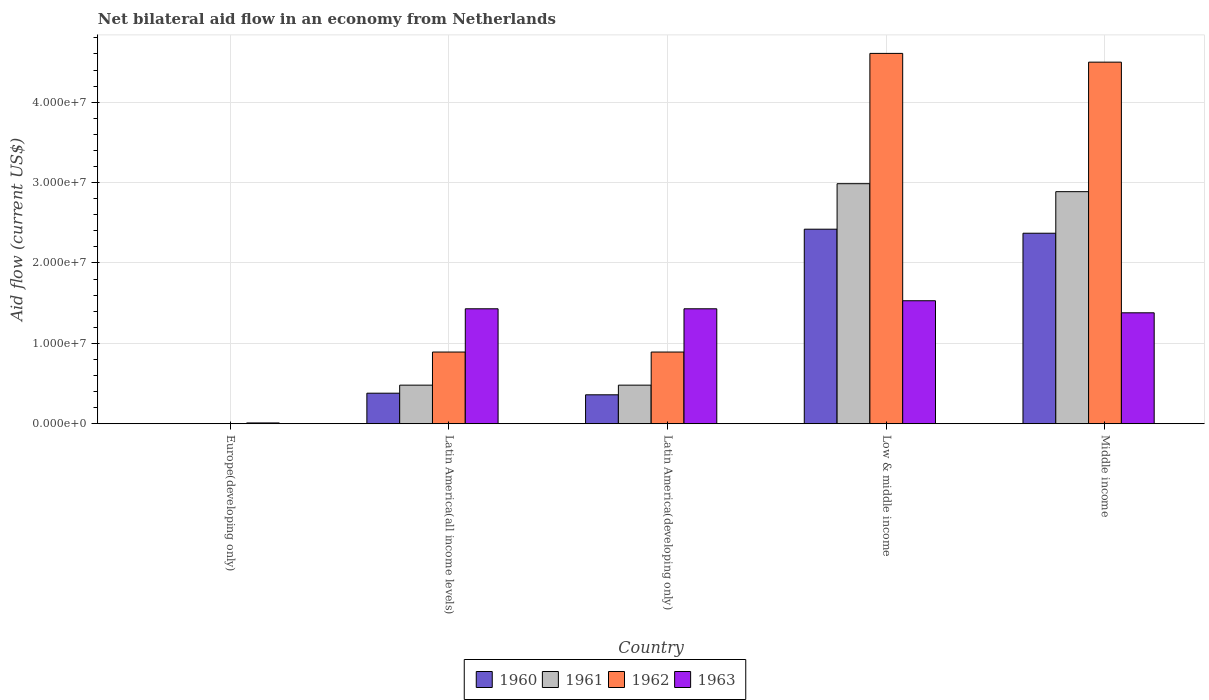How many different coloured bars are there?
Provide a succinct answer. 4. What is the label of the 5th group of bars from the left?
Ensure brevity in your answer.  Middle income. In how many cases, is the number of bars for a given country not equal to the number of legend labels?
Your response must be concise. 1. What is the net bilateral aid flow in 1962 in Europe(developing only)?
Give a very brief answer. 0. Across all countries, what is the maximum net bilateral aid flow in 1961?
Your answer should be very brief. 2.99e+07. Across all countries, what is the minimum net bilateral aid flow in 1961?
Your response must be concise. 0. In which country was the net bilateral aid flow in 1961 maximum?
Provide a succinct answer. Low & middle income. What is the total net bilateral aid flow in 1963 in the graph?
Make the answer very short. 5.78e+07. What is the difference between the net bilateral aid flow in 1961 in Low & middle income and the net bilateral aid flow in 1963 in Latin America(all income levels)?
Your response must be concise. 1.56e+07. What is the average net bilateral aid flow in 1963 per country?
Your answer should be very brief. 1.16e+07. What is the ratio of the net bilateral aid flow in 1962 in Latin America(all income levels) to that in Middle income?
Offer a terse response. 0.2. Is the difference between the net bilateral aid flow in 1960 in Latin America(all income levels) and Middle income greater than the difference between the net bilateral aid flow in 1961 in Latin America(all income levels) and Middle income?
Provide a short and direct response. Yes. What is the difference between the highest and the second highest net bilateral aid flow in 1963?
Offer a very short reply. 1.00e+06. What is the difference between the highest and the lowest net bilateral aid flow in 1963?
Your answer should be very brief. 1.52e+07. In how many countries, is the net bilateral aid flow in 1960 greater than the average net bilateral aid flow in 1960 taken over all countries?
Your answer should be compact. 2. Is the sum of the net bilateral aid flow in 1960 in Latin America(developing only) and Low & middle income greater than the maximum net bilateral aid flow in 1963 across all countries?
Make the answer very short. Yes. Is it the case that in every country, the sum of the net bilateral aid flow in 1962 and net bilateral aid flow in 1963 is greater than the net bilateral aid flow in 1960?
Offer a very short reply. Yes. How many countries are there in the graph?
Provide a succinct answer. 5. Are the values on the major ticks of Y-axis written in scientific E-notation?
Provide a succinct answer. Yes. Does the graph contain grids?
Keep it short and to the point. Yes. Where does the legend appear in the graph?
Ensure brevity in your answer.  Bottom center. How many legend labels are there?
Offer a very short reply. 4. What is the title of the graph?
Ensure brevity in your answer.  Net bilateral aid flow in an economy from Netherlands. Does "2015" appear as one of the legend labels in the graph?
Your answer should be compact. No. What is the Aid flow (current US$) in 1960 in Europe(developing only)?
Offer a very short reply. 0. What is the Aid flow (current US$) in 1961 in Europe(developing only)?
Provide a short and direct response. 0. What is the Aid flow (current US$) in 1962 in Europe(developing only)?
Make the answer very short. 0. What is the Aid flow (current US$) in 1963 in Europe(developing only)?
Keep it short and to the point. 1.00e+05. What is the Aid flow (current US$) of 1960 in Latin America(all income levels)?
Your response must be concise. 3.80e+06. What is the Aid flow (current US$) of 1961 in Latin America(all income levels)?
Offer a terse response. 4.80e+06. What is the Aid flow (current US$) of 1962 in Latin America(all income levels)?
Provide a succinct answer. 8.92e+06. What is the Aid flow (current US$) of 1963 in Latin America(all income levels)?
Your answer should be compact. 1.43e+07. What is the Aid flow (current US$) in 1960 in Latin America(developing only)?
Make the answer very short. 3.60e+06. What is the Aid flow (current US$) of 1961 in Latin America(developing only)?
Give a very brief answer. 4.80e+06. What is the Aid flow (current US$) of 1962 in Latin America(developing only)?
Give a very brief answer. 8.92e+06. What is the Aid flow (current US$) of 1963 in Latin America(developing only)?
Keep it short and to the point. 1.43e+07. What is the Aid flow (current US$) of 1960 in Low & middle income?
Give a very brief answer. 2.42e+07. What is the Aid flow (current US$) in 1961 in Low & middle income?
Give a very brief answer. 2.99e+07. What is the Aid flow (current US$) of 1962 in Low & middle income?
Ensure brevity in your answer.  4.61e+07. What is the Aid flow (current US$) of 1963 in Low & middle income?
Make the answer very short. 1.53e+07. What is the Aid flow (current US$) in 1960 in Middle income?
Keep it short and to the point. 2.37e+07. What is the Aid flow (current US$) in 1961 in Middle income?
Provide a succinct answer. 2.89e+07. What is the Aid flow (current US$) in 1962 in Middle income?
Your answer should be compact. 4.50e+07. What is the Aid flow (current US$) of 1963 in Middle income?
Offer a terse response. 1.38e+07. Across all countries, what is the maximum Aid flow (current US$) of 1960?
Your response must be concise. 2.42e+07. Across all countries, what is the maximum Aid flow (current US$) of 1961?
Your answer should be very brief. 2.99e+07. Across all countries, what is the maximum Aid flow (current US$) of 1962?
Offer a terse response. 4.61e+07. Across all countries, what is the maximum Aid flow (current US$) of 1963?
Provide a short and direct response. 1.53e+07. Across all countries, what is the minimum Aid flow (current US$) in 1961?
Provide a succinct answer. 0. Across all countries, what is the minimum Aid flow (current US$) in 1962?
Provide a succinct answer. 0. What is the total Aid flow (current US$) of 1960 in the graph?
Your response must be concise. 5.53e+07. What is the total Aid flow (current US$) of 1961 in the graph?
Give a very brief answer. 6.83e+07. What is the total Aid flow (current US$) of 1962 in the graph?
Keep it short and to the point. 1.09e+08. What is the total Aid flow (current US$) of 1963 in the graph?
Your answer should be very brief. 5.78e+07. What is the difference between the Aid flow (current US$) in 1963 in Europe(developing only) and that in Latin America(all income levels)?
Give a very brief answer. -1.42e+07. What is the difference between the Aid flow (current US$) of 1963 in Europe(developing only) and that in Latin America(developing only)?
Give a very brief answer. -1.42e+07. What is the difference between the Aid flow (current US$) of 1963 in Europe(developing only) and that in Low & middle income?
Offer a very short reply. -1.52e+07. What is the difference between the Aid flow (current US$) in 1963 in Europe(developing only) and that in Middle income?
Your answer should be very brief. -1.37e+07. What is the difference between the Aid flow (current US$) of 1960 in Latin America(all income levels) and that in Latin America(developing only)?
Ensure brevity in your answer.  2.00e+05. What is the difference between the Aid flow (current US$) in 1963 in Latin America(all income levels) and that in Latin America(developing only)?
Your answer should be very brief. 0. What is the difference between the Aid flow (current US$) of 1960 in Latin America(all income levels) and that in Low & middle income?
Make the answer very short. -2.04e+07. What is the difference between the Aid flow (current US$) of 1961 in Latin America(all income levels) and that in Low & middle income?
Ensure brevity in your answer.  -2.51e+07. What is the difference between the Aid flow (current US$) in 1962 in Latin America(all income levels) and that in Low & middle income?
Provide a succinct answer. -3.72e+07. What is the difference between the Aid flow (current US$) of 1963 in Latin America(all income levels) and that in Low & middle income?
Provide a succinct answer. -1.00e+06. What is the difference between the Aid flow (current US$) in 1960 in Latin America(all income levels) and that in Middle income?
Keep it short and to the point. -1.99e+07. What is the difference between the Aid flow (current US$) in 1961 in Latin America(all income levels) and that in Middle income?
Your response must be concise. -2.41e+07. What is the difference between the Aid flow (current US$) of 1962 in Latin America(all income levels) and that in Middle income?
Offer a very short reply. -3.61e+07. What is the difference between the Aid flow (current US$) of 1963 in Latin America(all income levels) and that in Middle income?
Your response must be concise. 5.00e+05. What is the difference between the Aid flow (current US$) of 1960 in Latin America(developing only) and that in Low & middle income?
Your response must be concise. -2.06e+07. What is the difference between the Aid flow (current US$) of 1961 in Latin America(developing only) and that in Low & middle income?
Keep it short and to the point. -2.51e+07. What is the difference between the Aid flow (current US$) in 1962 in Latin America(developing only) and that in Low & middle income?
Offer a terse response. -3.72e+07. What is the difference between the Aid flow (current US$) in 1960 in Latin America(developing only) and that in Middle income?
Your answer should be very brief. -2.01e+07. What is the difference between the Aid flow (current US$) in 1961 in Latin America(developing only) and that in Middle income?
Offer a terse response. -2.41e+07. What is the difference between the Aid flow (current US$) of 1962 in Latin America(developing only) and that in Middle income?
Give a very brief answer. -3.61e+07. What is the difference between the Aid flow (current US$) of 1961 in Low & middle income and that in Middle income?
Offer a very short reply. 9.90e+05. What is the difference between the Aid flow (current US$) in 1962 in Low & middle income and that in Middle income?
Keep it short and to the point. 1.09e+06. What is the difference between the Aid flow (current US$) in 1963 in Low & middle income and that in Middle income?
Keep it short and to the point. 1.50e+06. What is the difference between the Aid flow (current US$) in 1960 in Latin America(all income levels) and the Aid flow (current US$) in 1962 in Latin America(developing only)?
Your answer should be very brief. -5.12e+06. What is the difference between the Aid flow (current US$) in 1960 in Latin America(all income levels) and the Aid flow (current US$) in 1963 in Latin America(developing only)?
Ensure brevity in your answer.  -1.05e+07. What is the difference between the Aid flow (current US$) in 1961 in Latin America(all income levels) and the Aid flow (current US$) in 1962 in Latin America(developing only)?
Provide a succinct answer. -4.12e+06. What is the difference between the Aid flow (current US$) of 1961 in Latin America(all income levels) and the Aid flow (current US$) of 1963 in Latin America(developing only)?
Provide a short and direct response. -9.50e+06. What is the difference between the Aid flow (current US$) of 1962 in Latin America(all income levels) and the Aid flow (current US$) of 1963 in Latin America(developing only)?
Your answer should be compact. -5.38e+06. What is the difference between the Aid flow (current US$) in 1960 in Latin America(all income levels) and the Aid flow (current US$) in 1961 in Low & middle income?
Your response must be concise. -2.61e+07. What is the difference between the Aid flow (current US$) of 1960 in Latin America(all income levels) and the Aid flow (current US$) of 1962 in Low & middle income?
Your answer should be compact. -4.23e+07. What is the difference between the Aid flow (current US$) of 1960 in Latin America(all income levels) and the Aid flow (current US$) of 1963 in Low & middle income?
Provide a succinct answer. -1.15e+07. What is the difference between the Aid flow (current US$) in 1961 in Latin America(all income levels) and the Aid flow (current US$) in 1962 in Low & middle income?
Keep it short and to the point. -4.13e+07. What is the difference between the Aid flow (current US$) of 1961 in Latin America(all income levels) and the Aid flow (current US$) of 1963 in Low & middle income?
Your answer should be compact. -1.05e+07. What is the difference between the Aid flow (current US$) of 1962 in Latin America(all income levels) and the Aid flow (current US$) of 1963 in Low & middle income?
Your response must be concise. -6.38e+06. What is the difference between the Aid flow (current US$) in 1960 in Latin America(all income levels) and the Aid flow (current US$) in 1961 in Middle income?
Your answer should be very brief. -2.51e+07. What is the difference between the Aid flow (current US$) in 1960 in Latin America(all income levels) and the Aid flow (current US$) in 1962 in Middle income?
Provide a short and direct response. -4.12e+07. What is the difference between the Aid flow (current US$) in 1960 in Latin America(all income levels) and the Aid flow (current US$) in 1963 in Middle income?
Your answer should be compact. -1.00e+07. What is the difference between the Aid flow (current US$) in 1961 in Latin America(all income levels) and the Aid flow (current US$) in 1962 in Middle income?
Offer a very short reply. -4.02e+07. What is the difference between the Aid flow (current US$) of 1961 in Latin America(all income levels) and the Aid flow (current US$) of 1963 in Middle income?
Offer a very short reply. -9.00e+06. What is the difference between the Aid flow (current US$) of 1962 in Latin America(all income levels) and the Aid flow (current US$) of 1963 in Middle income?
Give a very brief answer. -4.88e+06. What is the difference between the Aid flow (current US$) in 1960 in Latin America(developing only) and the Aid flow (current US$) in 1961 in Low & middle income?
Provide a short and direct response. -2.63e+07. What is the difference between the Aid flow (current US$) in 1960 in Latin America(developing only) and the Aid flow (current US$) in 1962 in Low & middle income?
Provide a short and direct response. -4.25e+07. What is the difference between the Aid flow (current US$) of 1960 in Latin America(developing only) and the Aid flow (current US$) of 1963 in Low & middle income?
Your answer should be compact. -1.17e+07. What is the difference between the Aid flow (current US$) of 1961 in Latin America(developing only) and the Aid flow (current US$) of 1962 in Low & middle income?
Ensure brevity in your answer.  -4.13e+07. What is the difference between the Aid flow (current US$) of 1961 in Latin America(developing only) and the Aid flow (current US$) of 1963 in Low & middle income?
Provide a succinct answer. -1.05e+07. What is the difference between the Aid flow (current US$) of 1962 in Latin America(developing only) and the Aid flow (current US$) of 1963 in Low & middle income?
Provide a short and direct response. -6.38e+06. What is the difference between the Aid flow (current US$) in 1960 in Latin America(developing only) and the Aid flow (current US$) in 1961 in Middle income?
Give a very brief answer. -2.53e+07. What is the difference between the Aid flow (current US$) in 1960 in Latin America(developing only) and the Aid flow (current US$) in 1962 in Middle income?
Provide a succinct answer. -4.14e+07. What is the difference between the Aid flow (current US$) of 1960 in Latin America(developing only) and the Aid flow (current US$) of 1963 in Middle income?
Offer a very short reply. -1.02e+07. What is the difference between the Aid flow (current US$) of 1961 in Latin America(developing only) and the Aid flow (current US$) of 1962 in Middle income?
Provide a succinct answer. -4.02e+07. What is the difference between the Aid flow (current US$) in 1961 in Latin America(developing only) and the Aid flow (current US$) in 1963 in Middle income?
Make the answer very short. -9.00e+06. What is the difference between the Aid flow (current US$) of 1962 in Latin America(developing only) and the Aid flow (current US$) of 1963 in Middle income?
Your answer should be very brief. -4.88e+06. What is the difference between the Aid flow (current US$) in 1960 in Low & middle income and the Aid flow (current US$) in 1961 in Middle income?
Your answer should be very brief. -4.67e+06. What is the difference between the Aid flow (current US$) in 1960 in Low & middle income and the Aid flow (current US$) in 1962 in Middle income?
Provide a succinct answer. -2.08e+07. What is the difference between the Aid flow (current US$) in 1960 in Low & middle income and the Aid flow (current US$) in 1963 in Middle income?
Provide a short and direct response. 1.04e+07. What is the difference between the Aid flow (current US$) of 1961 in Low & middle income and the Aid flow (current US$) of 1962 in Middle income?
Keep it short and to the point. -1.51e+07. What is the difference between the Aid flow (current US$) of 1961 in Low & middle income and the Aid flow (current US$) of 1963 in Middle income?
Give a very brief answer. 1.61e+07. What is the difference between the Aid flow (current US$) of 1962 in Low & middle income and the Aid flow (current US$) of 1963 in Middle income?
Your answer should be compact. 3.23e+07. What is the average Aid flow (current US$) in 1960 per country?
Provide a short and direct response. 1.11e+07. What is the average Aid flow (current US$) of 1961 per country?
Make the answer very short. 1.37e+07. What is the average Aid flow (current US$) of 1962 per country?
Make the answer very short. 2.18e+07. What is the average Aid flow (current US$) in 1963 per country?
Offer a terse response. 1.16e+07. What is the difference between the Aid flow (current US$) of 1960 and Aid flow (current US$) of 1961 in Latin America(all income levels)?
Provide a succinct answer. -1.00e+06. What is the difference between the Aid flow (current US$) in 1960 and Aid flow (current US$) in 1962 in Latin America(all income levels)?
Offer a very short reply. -5.12e+06. What is the difference between the Aid flow (current US$) of 1960 and Aid flow (current US$) of 1963 in Latin America(all income levels)?
Give a very brief answer. -1.05e+07. What is the difference between the Aid flow (current US$) of 1961 and Aid flow (current US$) of 1962 in Latin America(all income levels)?
Your answer should be very brief. -4.12e+06. What is the difference between the Aid flow (current US$) of 1961 and Aid flow (current US$) of 1963 in Latin America(all income levels)?
Make the answer very short. -9.50e+06. What is the difference between the Aid flow (current US$) in 1962 and Aid flow (current US$) in 1963 in Latin America(all income levels)?
Offer a terse response. -5.38e+06. What is the difference between the Aid flow (current US$) of 1960 and Aid flow (current US$) of 1961 in Latin America(developing only)?
Ensure brevity in your answer.  -1.20e+06. What is the difference between the Aid flow (current US$) of 1960 and Aid flow (current US$) of 1962 in Latin America(developing only)?
Provide a succinct answer. -5.32e+06. What is the difference between the Aid flow (current US$) in 1960 and Aid flow (current US$) in 1963 in Latin America(developing only)?
Give a very brief answer. -1.07e+07. What is the difference between the Aid flow (current US$) of 1961 and Aid flow (current US$) of 1962 in Latin America(developing only)?
Keep it short and to the point. -4.12e+06. What is the difference between the Aid flow (current US$) in 1961 and Aid flow (current US$) in 1963 in Latin America(developing only)?
Provide a succinct answer. -9.50e+06. What is the difference between the Aid flow (current US$) of 1962 and Aid flow (current US$) of 1963 in Latin America(developing only)?
Provide a short and direct response. -5.38e+06. What is the difference between the Aid flow (current US$) of 1960 and Aid flow (current US$) of 1961 in Low & middle income?
Ensure brevity in your answer.  -5.66e+06. What is the difference between the Aid flow (current US$) in 1960 and Aid flow (current US$) in 1962 in Low & middle income?
Provide a short and direct response. -2.19e+07. What is the difference between the Aid flow (current US$) in 1960 and Aid flow (current US$) in 1963 in Low & middle income?
Ensure brevity in your answer.  8.90e+06. What is the difference between the Aid flow (current US$) of 1961 and Aid flow (current US$) of 1962 in Low & middle income?
Your answer should be compact. -1.62e+07. What is the difference between the Aid flow (current US$) of 1961 and Aid flow (current US$) of 1963 in Low & middle income?
Give a very brief answer. 1.46e+07. What is the difference between the Aid flow (current US$) of 1962 and Aid flow (current US$) of 1963 in Low & middle income?
Provide a succinct answer. 3.08e+07. What is the difference between the Aid flow (current US$) in 1960 and Aid flow (current US$) in 1961 in Middle income?
Give a very brief answer. -5.17e+06. What is the difference between the Aid flow (current US$) in 1960 and Aid flow (current US$) in 1962 in Middle income?
Provide a short and direct response. -2.13e+07. What is the difference between the Aid flow (current US$) of 1960 and Aid flow (current US$) of 1963 in Middle income?
Offer a very short reply. 9.90e+06. What is the difference between the Aid flow (current US$) in 1961 and Aid flow (current US$) in 1962 in Middle income?
Offer a very short reply. -1.61e+07. What is the difference between the Aid flow (current US$) in 1961 and Aid flow (current US$) in 1963 in Middle income?
Give a very brief answer. 1.51e+07. What is the difference between the Aid flow (current US$) in 1962 and Aid flow (current US$) in 1963 in Middle income?
Make the answer very short. 3.12e+07. What is the ratio of the Aid flow (current US$) of 1963 in Europe(developing only) to that in Latin America(all income levels)?
Your response must be concise. 0.01. What is the ratio of the Aid flow (current US$) of 1963 in Europe(developing only) to that in Latin America(developing only)?
Provide a succinct answer. 0.01. What is the ratio of the Aid flow (current US$) of 1963 in Europe(developing only) to that in Low & middle income?
Provide a short and direct response. 0.01. What is the ratio of the Aid flow (current US$) in 1963 in Europe(developing only) to that in Middle income?
Ensure brevity in your answer.  0.01. What is the ratio of the Aid flow (current US$) in 1960 in Latin America(all income levels) to that in Latin America(developing only)?
Your response must be concise. 1.06. What is the ratio of the Aid flow (current US$) of 1961 in Latin America(all income levels) to that in Latin America(developing only)?
Keep it short and to the point. 1. What is the ratio of the Aid flow (current US$) in 1962 in Latin America(all income levels) to that in Latin America(developing only)?
Keep it short and to the point. 1. What is the ratio of the Aid flow (current US$) of 1963 in Latin America(all income levels) to that in Latin America(developing only)?
Offer a very short reply. 1. What is the ratio of the Aid flow (current US$) in 1960 in Latin America(all income levels) to that in Low & middle income?
Keep it short and to the point. 0.16. What is the ratio of the Aid flow (current US$) of 1961 in Latin America(all income levels) to that in Low & middle income?
Offer a very short reply. 0.16. What is the ratio of the Aid flow (current US$) of 1962 in Latin America(all income levels) to that in Low & middle income?
Your answer should be compact. 0.19. What is the ratio of the Aid flow (current US$) in 1963 in Latin America(all income levels) to that in Low & middle income?
Offer a very short reply. 0.93. What is the ratio of the Aid flow (current US$) in 1960 in Latin America(all income levels) to that in Middle income?
Offer a terse response. 0.16. What is the ratio of the Aid flow (current US$) in 1961 in Latin America(all income levels) to that in Middle income?
Your answer should be very brief. 0.17. What is the ratio of the Aid flow (current US$) in 1962 in Latin America(all income levels) to that in Middle income?
Make the answer very short. 0.2. What is the ratio of the Aid flow (current US$) of 1963 in Latin America(all income levels) to that in Middle income?
Offer a very short reply. 1.04. What is the ratio of the Aid flow (current US$) in 1960 in Latin America(developing only) to that in Low & middle income?
Your response must be concise. 0.15. What is the ratio of the Aid flow (current US$) of 1961 in Latin America(developing only) to that in Low & middle income?
Offer a terse response. 0.16. What is the ratio of the Aid flow (current US$) of 1962 in Latin America(developing only) to that in Low & middle income?
Provide a succinct answer. 0.19. What is the ratio of the Aid flow (current US$) of 1963 in Latin America(developing only) to that in Low & middle income?
Your response must be concise. 0.93. What is the ratio of the Aid flow (current US$) of 1960 in Latin America(developing only) to that in Middle income?
Ensure brevity in your answer.  0.15. What is the ratio of the Aid flow (current US$) of 1961 in Latin America(developing only) to that in Middle income?
Offer a terse response. 0.17. What is the ratio of the Aid flow (current US$) in 1962 in Latin America(developing only) to that in Middle income?
Ensure brevity in your answer.  0.2. What is the ratio of the Aid flow (current US$) of 1963 in Latin America(developing only) to that in Middle income?
Offer a terse response. 1.04. What is the ratio of the Aid flow (current US$) in 1960 in Low & middle income to that in Middle income?
Offer a very short reply. 1.02. What is the ratio of the Aid flow (current US$) in 1961 in Low & middle income to that in Middle income?
Offer a terse response. 1.03. What is the ratio of the Aid flow (current US$) of 1962 in Low & middle income to that in Middle income?
Offer a terse response. 1.02. What is the ratio of the Aid flow (current US$) of 1963 in Low & middle income to that in Middle income?
Offer a very short reply. 1.11. What is the difference between the highest and the second highest Aid flow (current US$) in 1960?
Ensure brevity in your answer.  5.00e+05. What is the difference between the highest and the second highest Aid flow (current US$) of 1961?
Offer a terse response. 9.90e+05. What is the difference between the highest and the second highest Aid flow (current US$) of 1962?
Make the answer very short. 1.09e+06. What is the difference between the highest and the second highest Aid flow (current US$) of 1963?
Keep it short and to the point. 1.00e+06. What is the difference between the highest and the lowest Aid flow (current US$) in 1960?
Provide a short and direct response. 2.42e+07. What is the difference between the highest and the lowest Aid flow (current US$) of 1961?
Your response must be concise. 2.99e+07. What is the difference between the highest and the lowest Aid flow (current US$) of 1962?
Your response must be concise. 4.61e+07. What is the difference between the highest and the lowest Aid flow (current US$) in 1963?
Offer a terse response. 1.52e+07. 